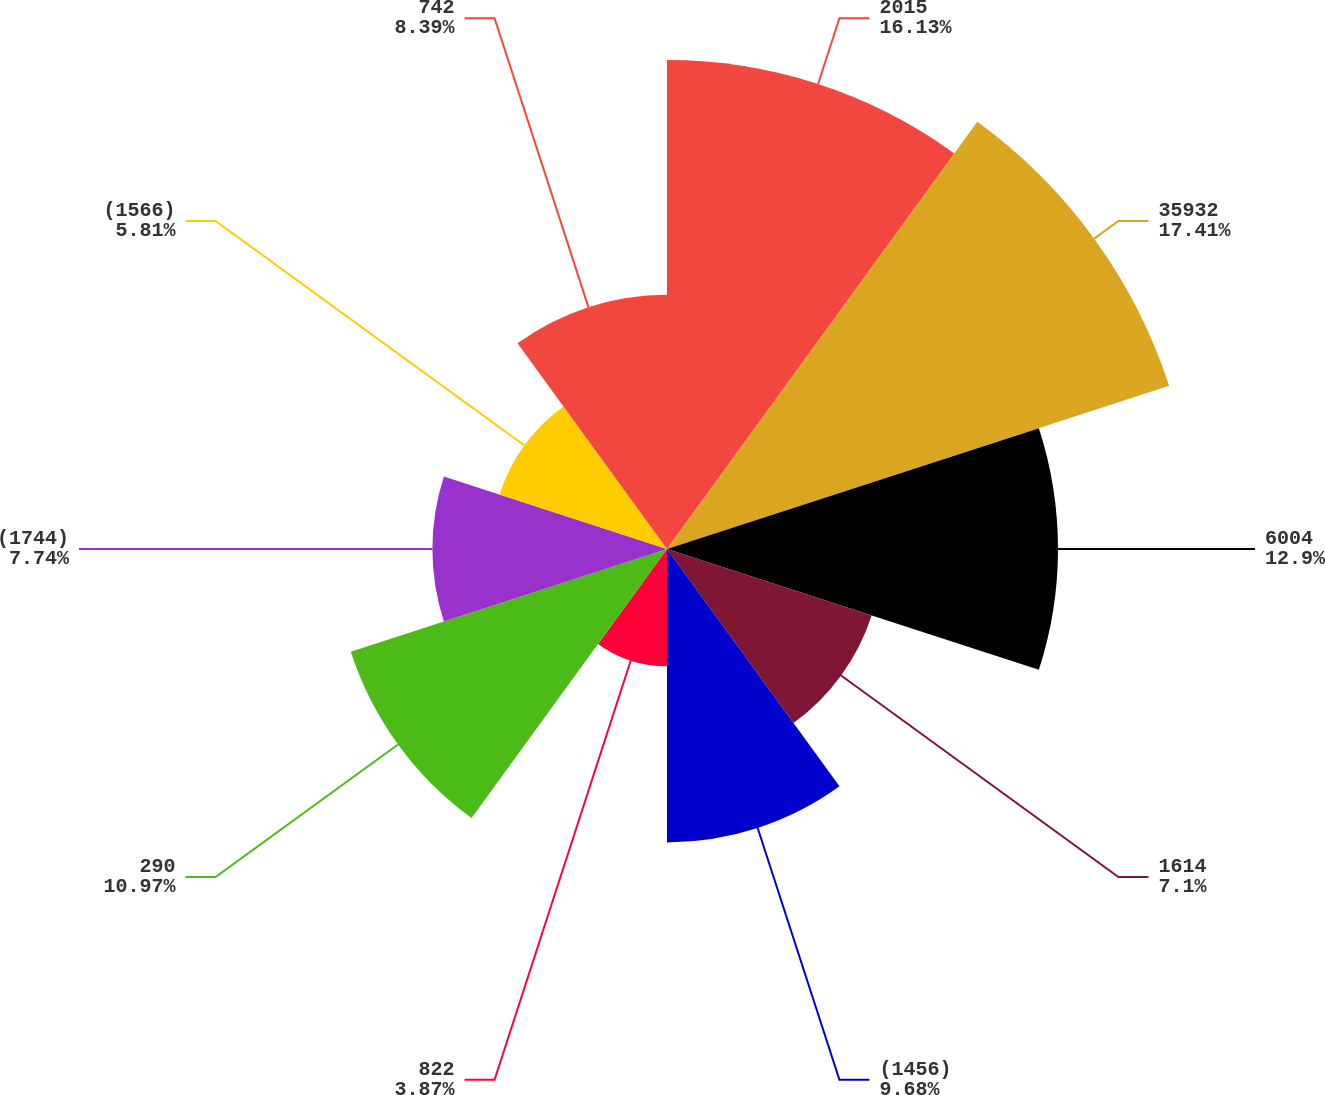Convert chart. <chart><loc_0><loc_0><loc_500><loc_500><pie_chart><fcel>2015<fcel>35932<fcel>6004<fcel>1614<fcel>(1456)<fcel>822<fcel>290<fcel>(1744)<fcel>(1566)<fcel>742<nl><fcel>16.13%<fcel>17.42%<fcel>12.9%<fcel>7.1%<fcel>9.68%<fcel>3.87%<fcel>10.97%<fcel>7.74%<fcel>5.81%<fcel>8.39%<nl></chart> 